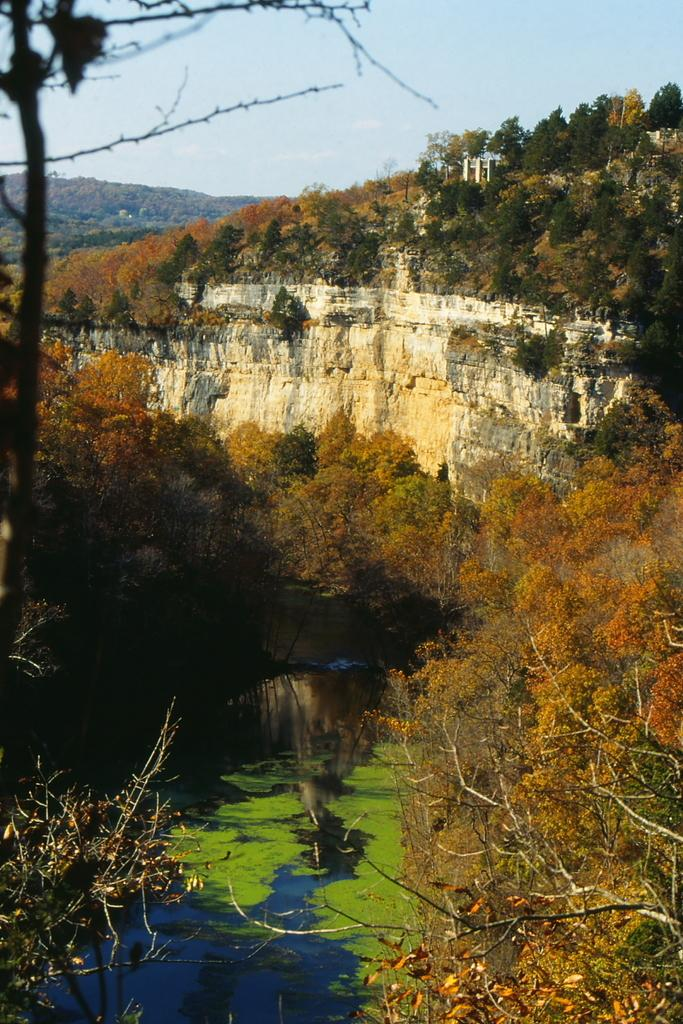What can be seen in the foreground of the picture? There are trees and a water body in the foreground of the picture, along with leaves. What is visible in the background of the picture? There are hills and trees in the background of the picture. How is the weather in the image? The sky is sunny, indicating a clear and pleasant day. Can you tell me how many people are adjusting their pleasure boats in the water body? There is no mention of people or pleasure boats in the image; it features trees, a water body, and leaves in the foreground, along with hills and trees in the background. 